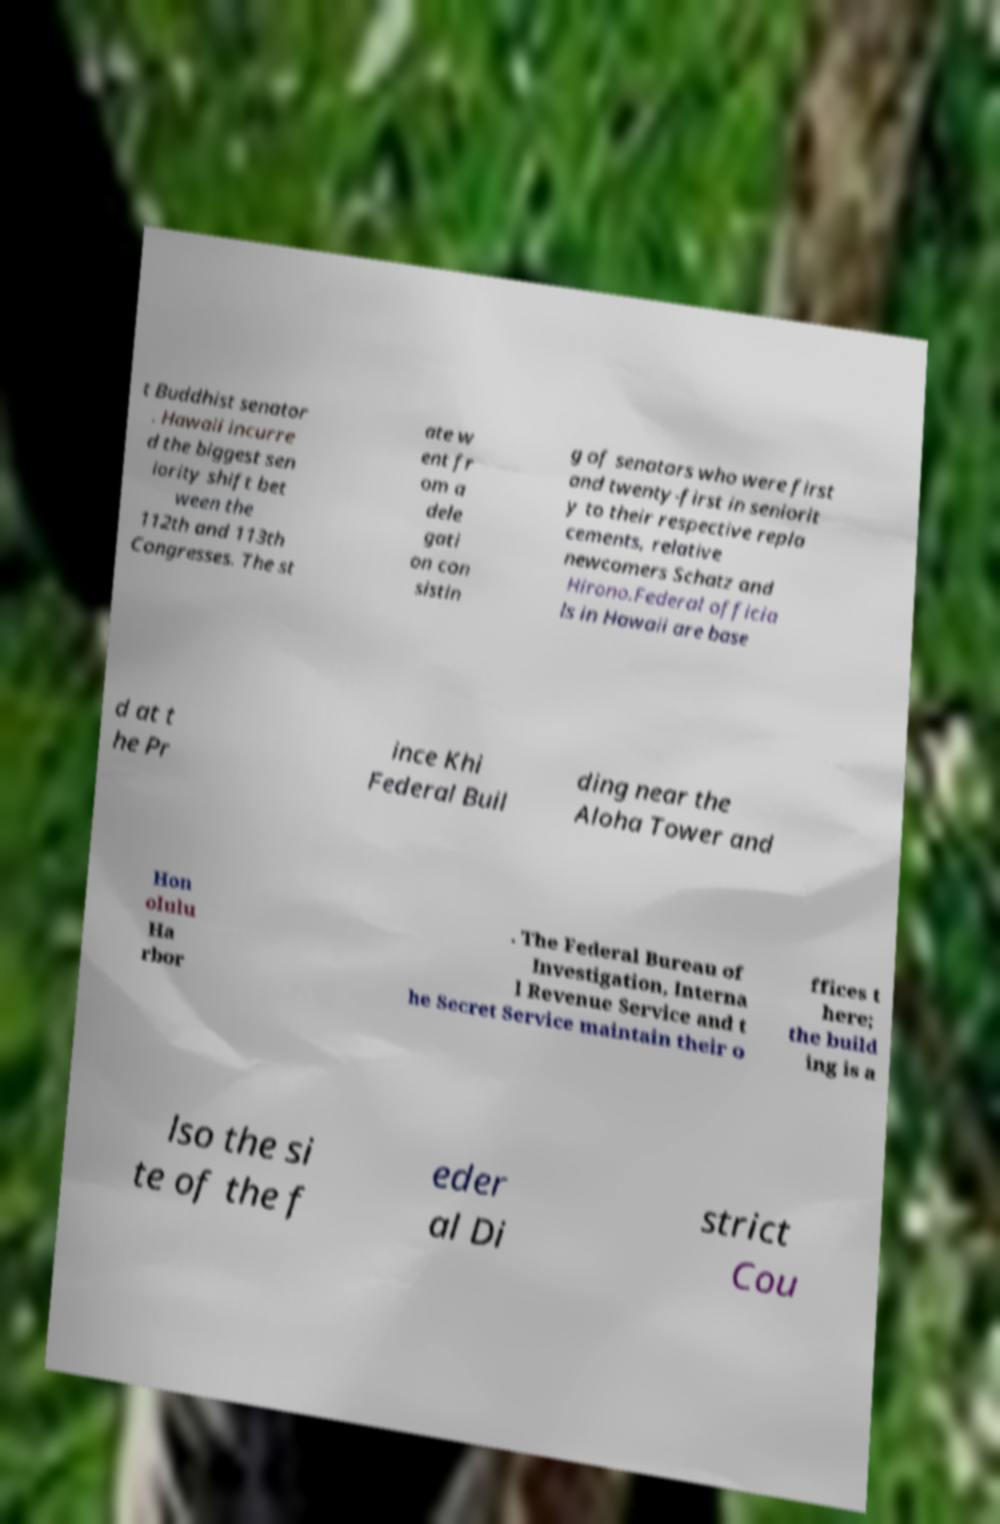Please identify and transcribe the text found in this image. t Buddhist senator . Hawaii incurre d the biggest sen iority shift bet ween the 112th and 113th Congresses. The st ate w ent fr om a dele gati on con sistin g of senators who were first and twenty-first in seniorit y to their respective repla cements, relative newcomers Schatz and Hirono.Federal officia ls in Hawaii are base d at t he Pr ince Khi Federal Buil ding near the Aloha Tower and Hon olulu Ha rbor . The Federal Bureau of Investigation, Interna l Revenue Service and t he Secret Service maintain their o ffices t here; the build ing is a lso the si te of the f eder al Di strict Cou 